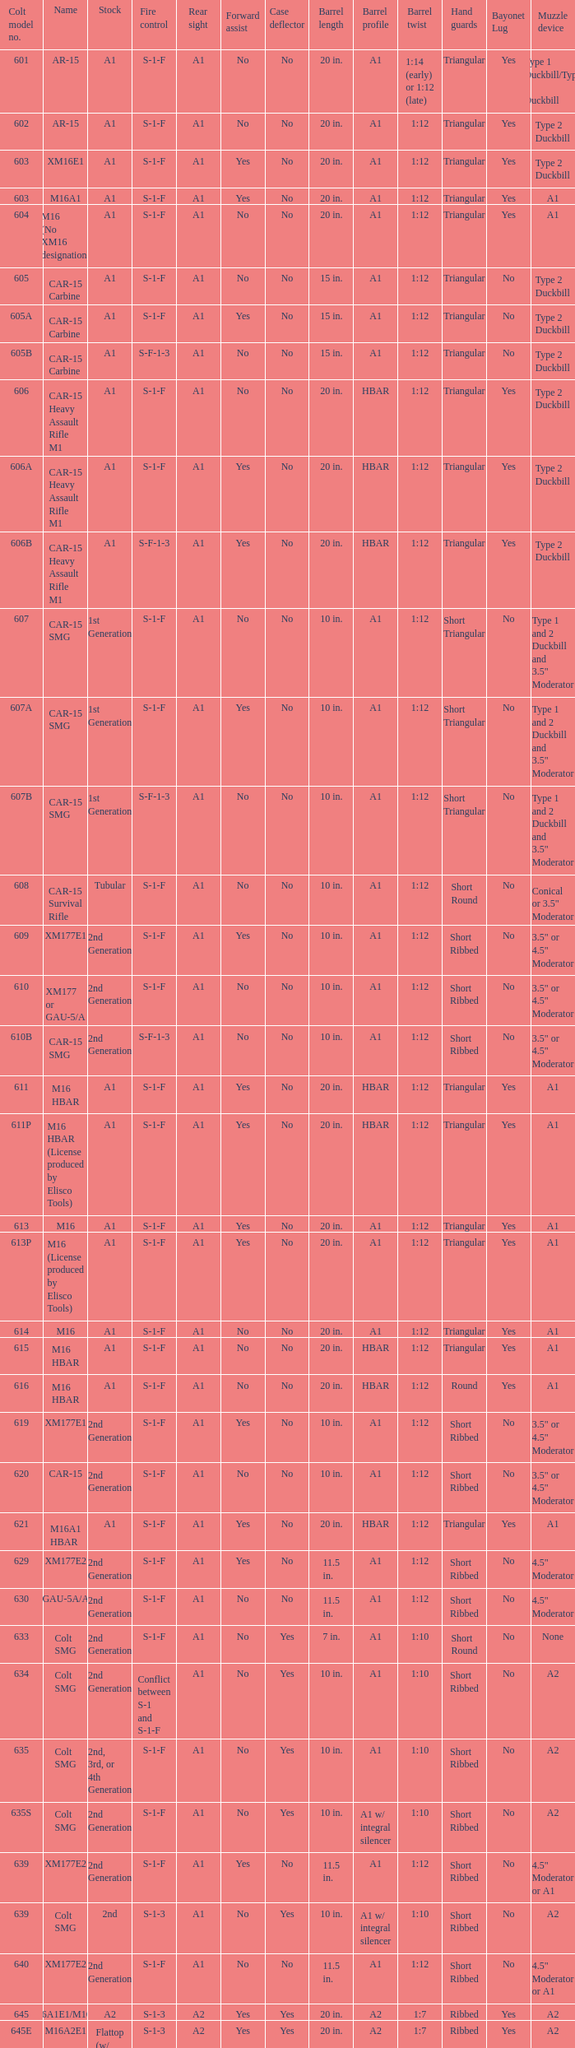What are the Colt model numbers of the models named GAU-5A/A, with no bayonet lug, no case deflector and stock of 2nd generation?  630, 649. 